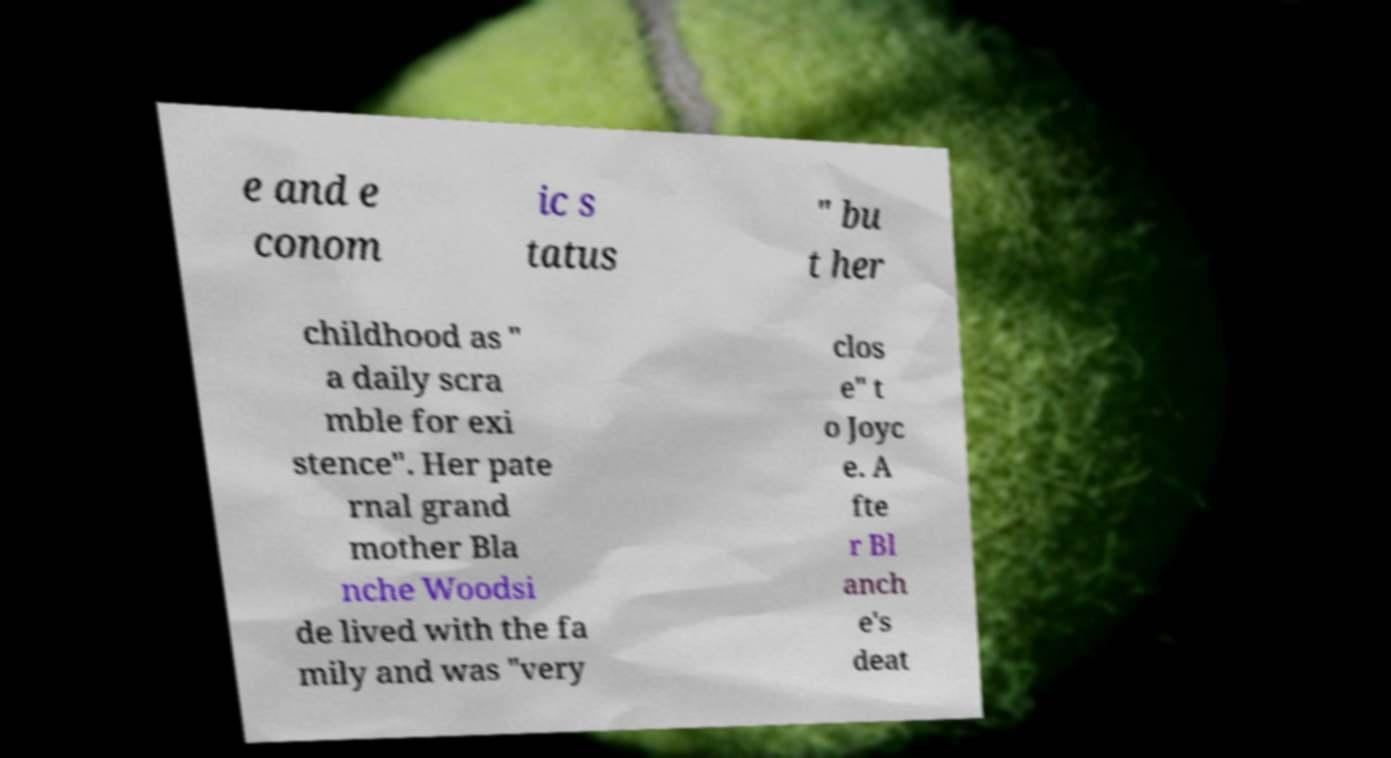Please identify and transcribe the text found in this image. e and e conom ic s tatus " bu t her childhood as " a daily scra mble for exi stence". Her pate rnal grand mother Bla nche Woodsi de lived with the fa mily and was "very clos e" t o Joyc e. A fte r Bl anch e's deat 